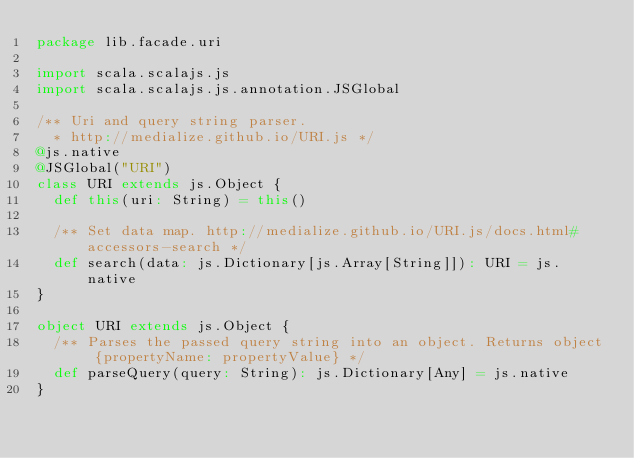<code> <loc_0><loc_0><loc_500><loc_500><_Scala_>package lib.facade.uri

import scala.scalajs.js
import scala.scalajs.js.annotation.JSGlobal

/** Uri and query string parser.
  * http://medialize.github.io/URI.js */
@js.native
@JSGlobal("URI")
class URI extends js.Object {
  def this(uri: String) = this()

  /** Set data map. http://medialize.github.io/URI.js/docs.html#accessors-search */
  def search(data: js.Dictionary[js.Array[String]]): URI = js.native
}

object URI extends js.Object {
  /** Parses the passed query string into an object. Returns object {propertyName: propertyValue} */
  def parseQuery(query: String): js.Dictionary[Any] = js.native
}</code> 